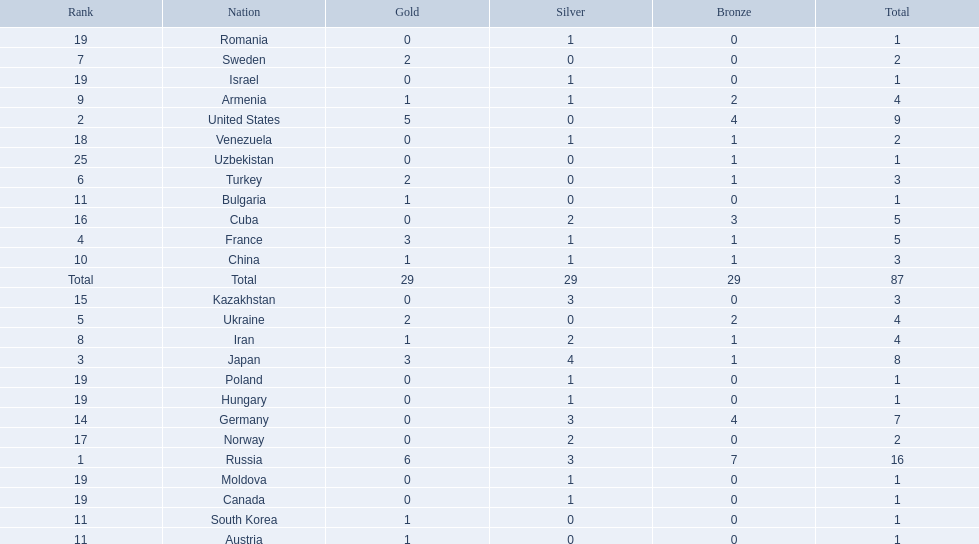What were the nations that participated in the 1995 world wrestling championships? Russia, United States, Japan, France, Ukraine, Turkey, Sweden, Iran, Armenia, China, Austria, Bulgaria, South Korea, Germany, Kazakhstan, Cuba, Norway, Venezuela, Canada, Hungary, Israel, Moldova, Poland, Romania, Uzbekistan. How many gold medals did the united states earn in the championship? 5. What amount of medals earner was greater than this value? 6. What country earned these medals? Russia. 